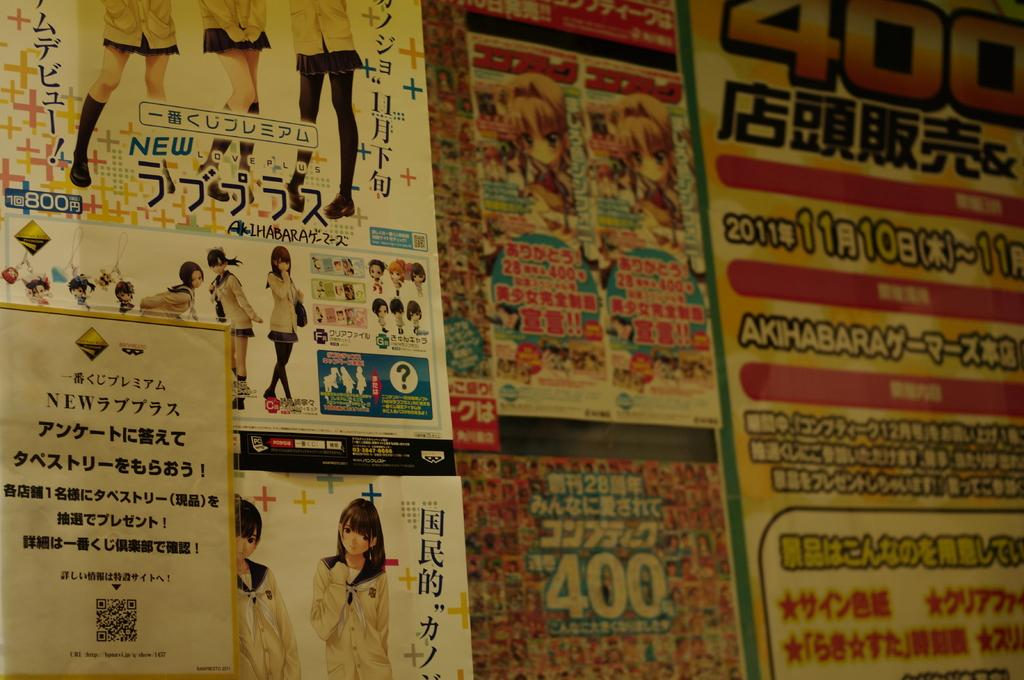<image>
Summarize the visual content of the image. the number 400 is on an ad in the back 